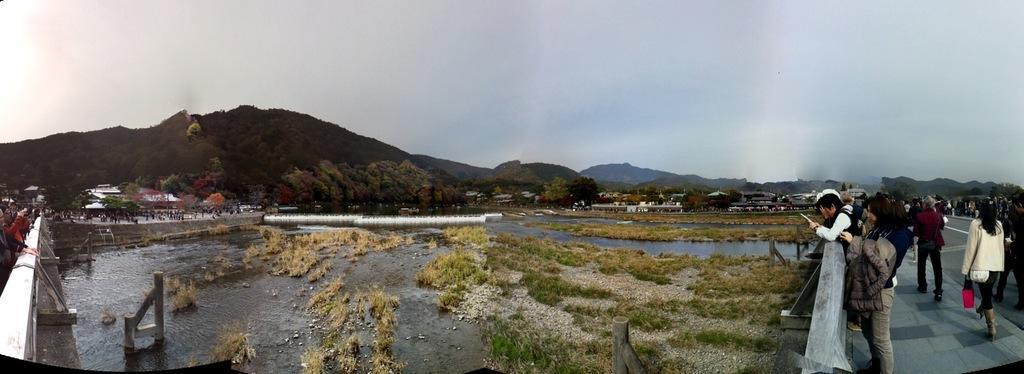Could you give a brief overview of what you see in this image? In the image there are few people walking on the right side on the bridge and some are on the left side, in the middle it seems to be small pond with grass in the front, in the back there are homes with trees all over it and in the background there are hills with trees and plants on it and above its sky. 